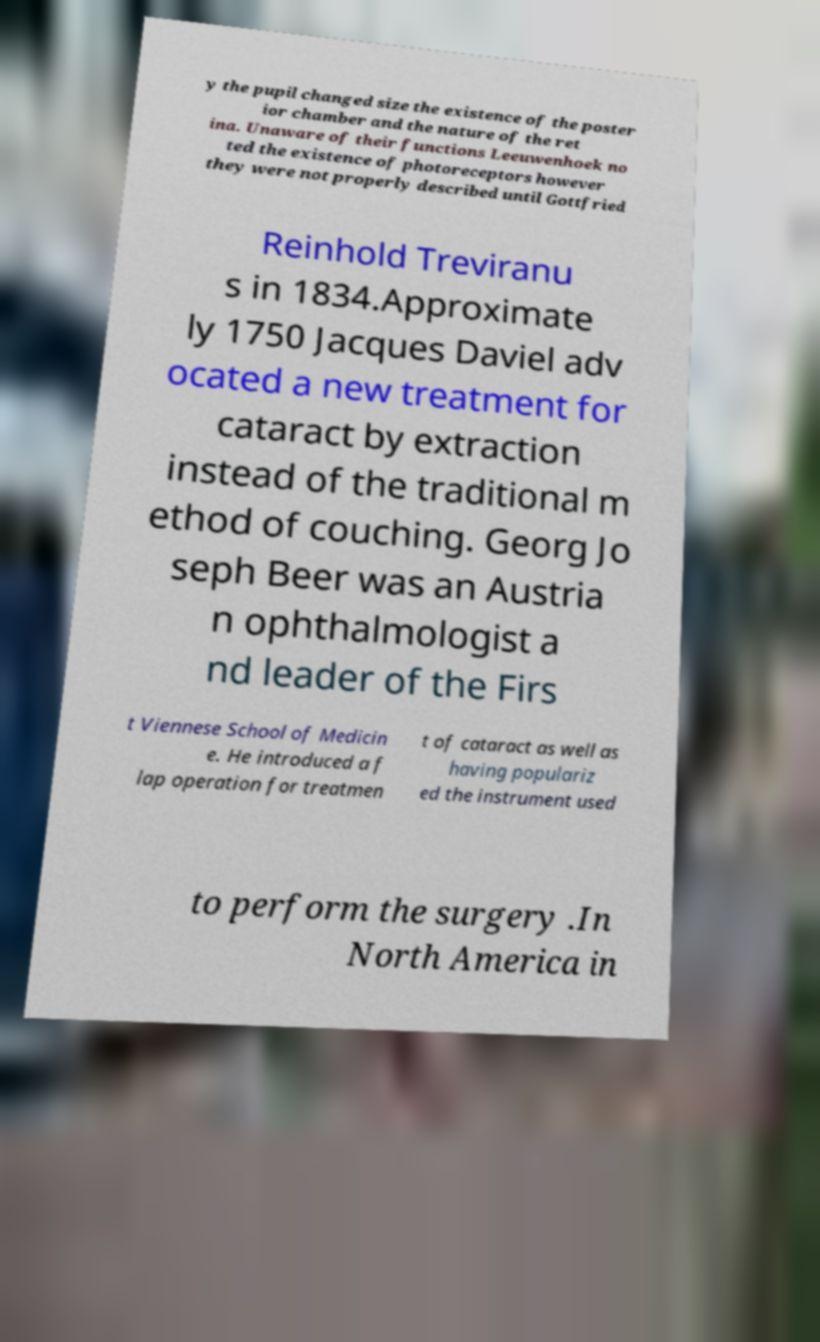What messages or text are displayed in this image? I need them in a readable, typed format. y the pupil changed size the existence of the poster ior chamber and the nature of the ret ina. Unaware of their functions Leeuwenhoek no ted the existence of photoreceptors however they were not properly described until Gottfried Reinhold Treviranu s in 1834.Approximate ly 1750 Jacques Daviel adv ocated a new treatment for cataract by extraction instead of the traditional m ethod of couching. Georg Jo seph Beer was an Austria n ophthalmologist a nd leader of the Firs t Viennese School of Medicin e. He introduced a f lap operation for treatmen t of cataract as well as having populariz ed the instrument used to perform the surgery .In North America in 